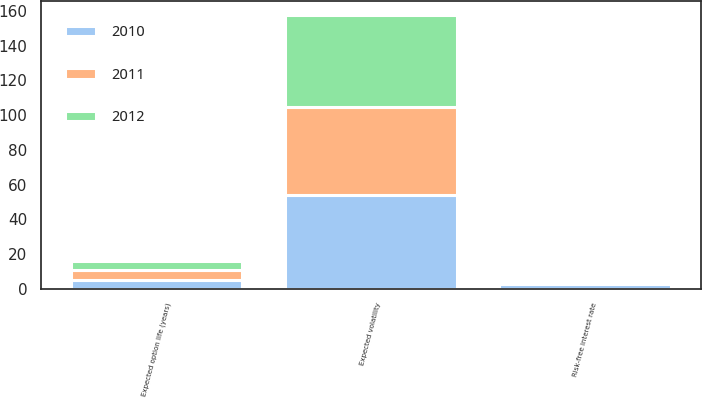<chart> <loc_0><loc_0><loc_500><loc_500><stacked_bar_chart><ecel><fcel>Risk-free interest rate<fcel>Expected option life (years)<fcel>Expected volatility<nl><fcel>2012<fcel>1.47<fcel>5.19<fcel>53.1<nl><fcel>2011<fcel>2.04<fcel>5.3<fcel>50.9<nl><fcel>2010<fcel>2.45<fcel>5.24<fcel>53.9<nl></chart> 